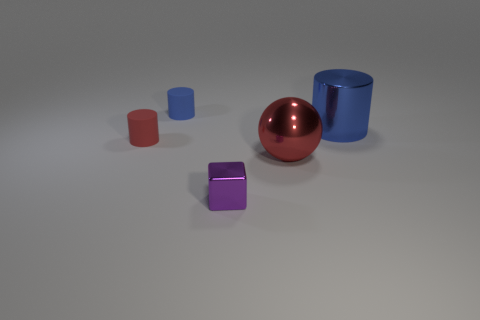What time of day or lighting conditions does the image appear to represent? The image appears to represent a scene with artificial lighting, suggesting an indoor environment rather than a specific time of day. 